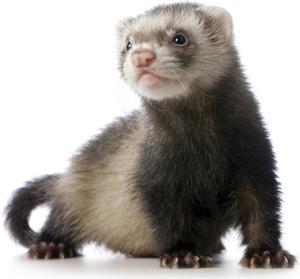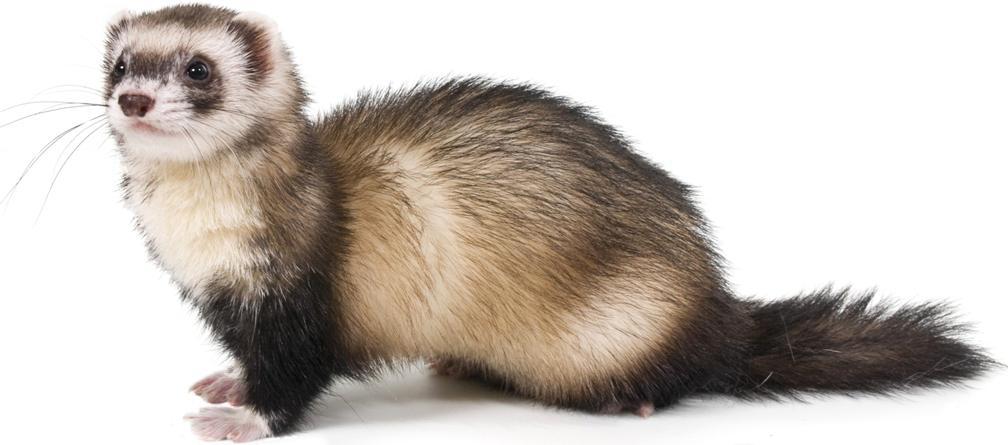The first image is the image on the left, the second image is the image on the right. Analyze the images presented: Is the assertion "There are two animals in the image on the right." valid? Answer yes or no. No. 